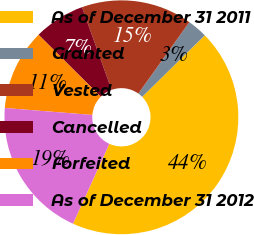Convert chart to OTSL. <chart><loc_0><loc_0><loc_500><loc_500><pie_chart><fcel>As of December 31 2011<fcel>Granted<fcel>Vested<fcel>Cancelled<fcel>Forfeited<fcel>As of December 31 2012<nl><fcel>44.15%<fcel>2.77%<fcel>15.34%<fcel>7.06%<fcel>11.2%<fcel>19.48%<nl></chart> 